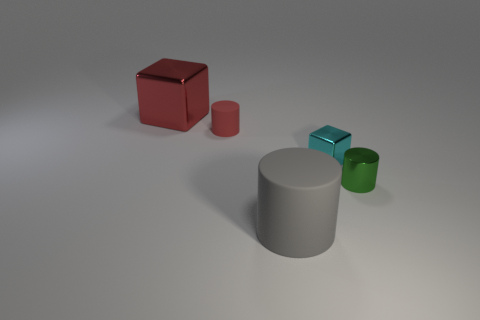What might be the purpose of the arrangement of these objects? The purpose isn't immediately clear, but it could be an artistic composition focusing on geometry and color contrasts, or perhaps a simple demonstration of 3D modeling and rendering techniques. Could this image be used in any educational context? Absolutely. This image could be quite useful in educational contexts, particularly for lessons on geometry, spatial awareness, properties of materials, and even basics of 3D graphics and color theory. 